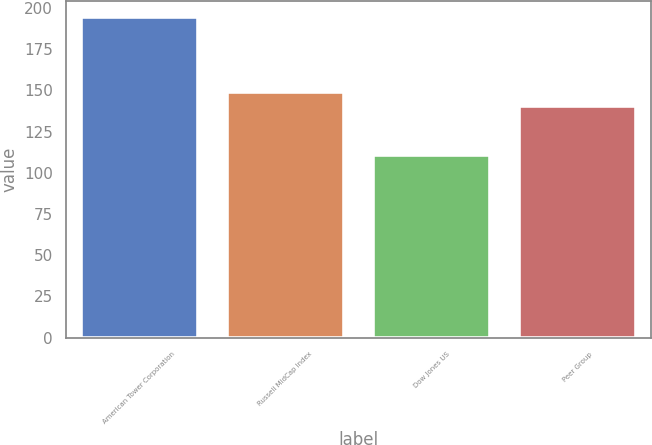Convert chart. <chart><loc_0><loc_0><loc_500><loc_500><bar_chart><fcel>American Tower Corporation<fcel>Russell MidCap Index<fcel>Dow Jones US<fcel>Peer Group<nl><fcel>194.3<fcel>148.84<fcel>110.85<fcel>140.5<nl></chart> 